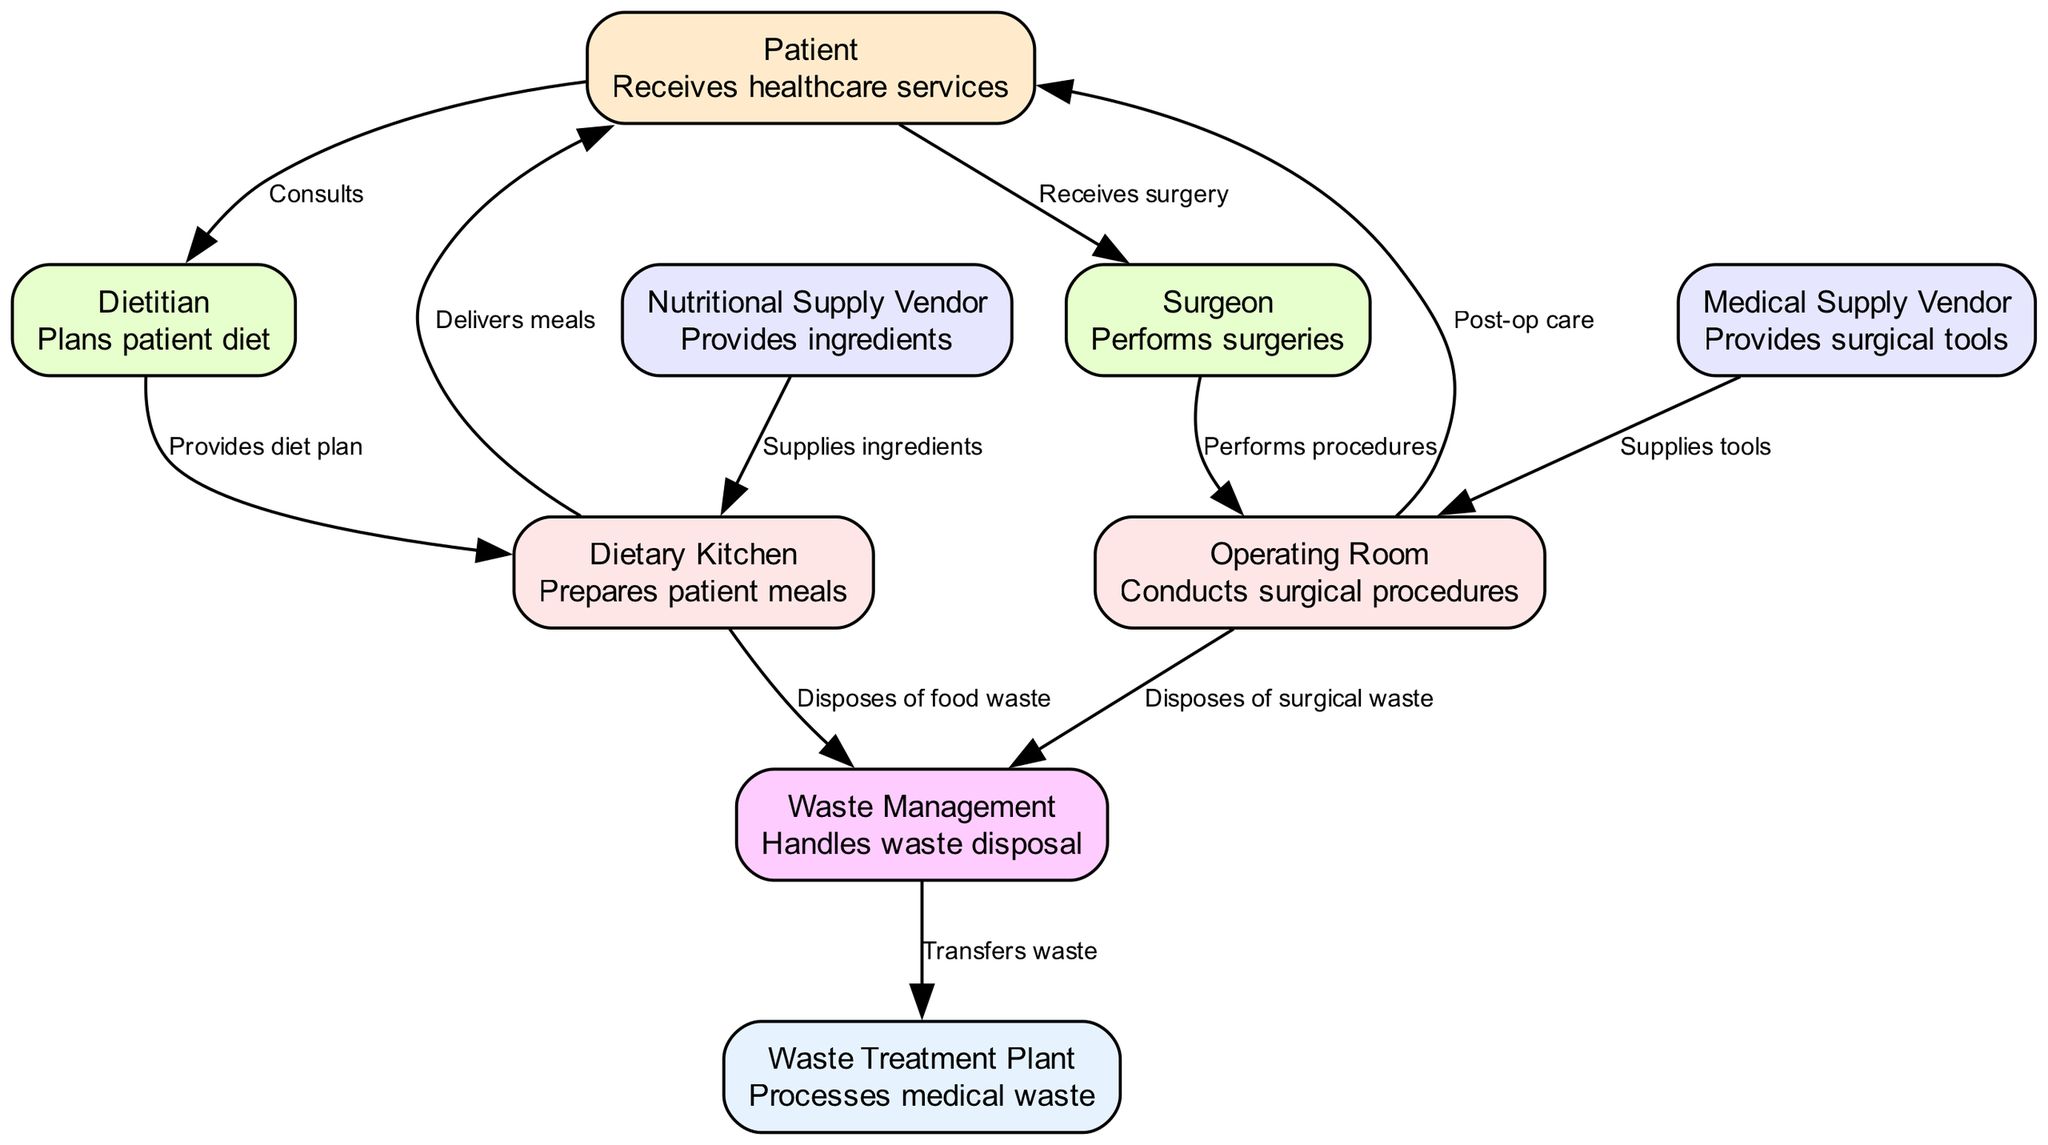What is the highest level in the hospital ecosystem? The highest level in the diagram is "Waste Treatment Plant," which is at level 6. It processes medical waste and serves at the final stage of the ecosystem.
Answer: Waste Treatment Plant How many edges are connected to the "Dietary Kitchen"? The "Dietary Kitchen" has three edges connected to it: one from the "Dietitian," one to the "Patient," and one to "Waste Management." This indicates the interactions it has within the ecosystem.
Answer: 3 What role does the "Surgeon" perform in the hospital ecosystem? The "Surgeon" performs surgeries, as indicated in the description associated with this node. It is a primary role providing critical healthcare services during the surgical process.
Answer: Performs surgeries Which two entities dispose of waste in the hospital ecosystem? The two entities that dispose of waste are the "Dietary Kitchen," which disposes of food waste, and the "Operating Room," which disposes of surgical waste. Both contribute to the overall waste management process.
Answer: Dietary Kitchen and Operating Room What is the relationship between the "Medical Supply Vendor" and the "Operating Room"? The "Medical Supply Vendor" supplies tools to the "Operating Room," indicating the direct support role it plays in ensuring that surgical procedures can be conducted effectively and safely.
Answer: Supplies tools What is the flow of food waste from the "Dietary Kitchen"? The flow of food waste from the "Dietary Kitchen" goes to "Waste Management," which then transfers the waste to the "Waste Treatment Plant." This process ensures that food waste is managed properly after meal delivery.
Answer: Waste Management How many levels are present in the hospital ecosystem? There are six distinct levels present in the hospital ecosystem, starting from the "Patient" at level 1 up to the "Waste Treatment Plant" at level 6. This illustrates the hierarchy and flow of services within the hospital.
Answer: 6 Which entity provides the diet plan to the "Dietary Kitchen"? The "Dietitian" provides the diet plan to the "Dietary Kitchen," indicating the essential role of planning in meal preparation for patients based on their healthcare needs.
Answer: Dietitian 